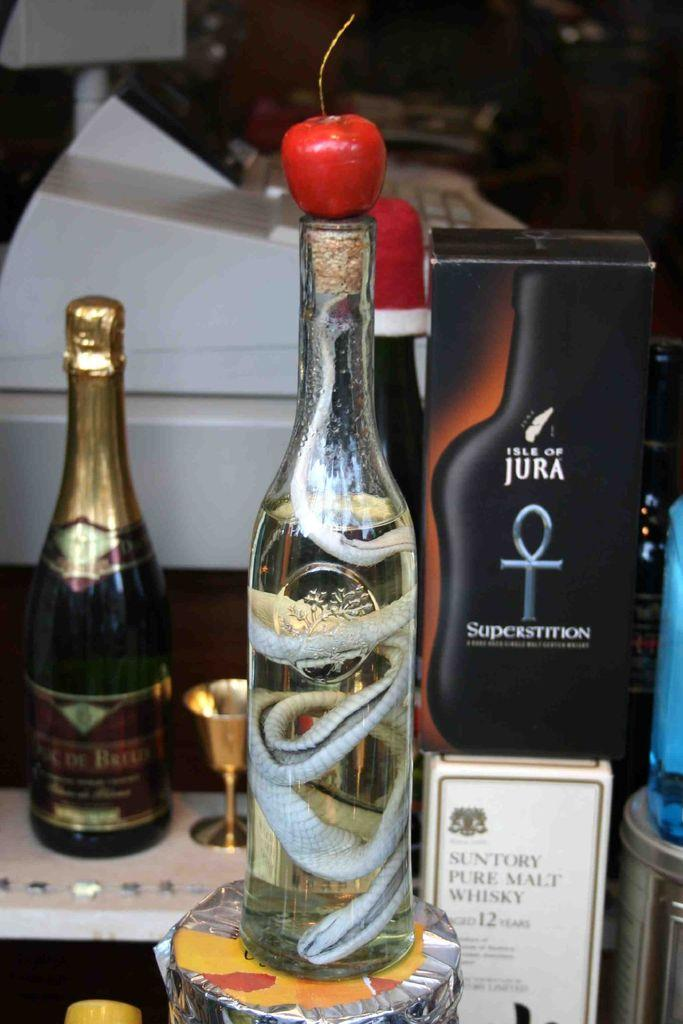How many bottles are on the table in the image? There are two bottles on the table in the image. What is located beside the bottles? There is a box beside the bottles. Is there any fruit visible in the image? Yes, there is a fruit placed on the bottleneck of one of the bottles. How many cherries are on the boundary of the image? There are no cherries present in the image, and the concept of a boundary is not applicable to this image. 